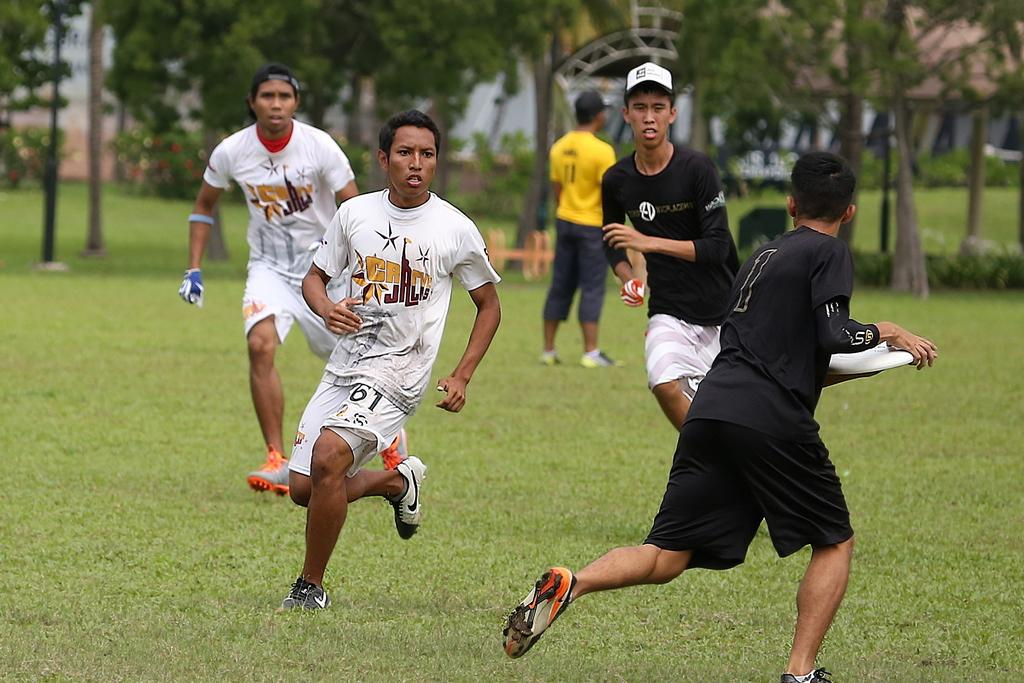What are the boys in the image doing? The boys are playing in the image. Where are the boys playing? The boys are playing on the grass. What type of vegetation can be seen in the image? There are trees and grass visible in the image. What type of pipe can be seen in the image? There is no pipe present in the image. Are the boys camping in the image? There is no indication in the image that the boys are camping. 